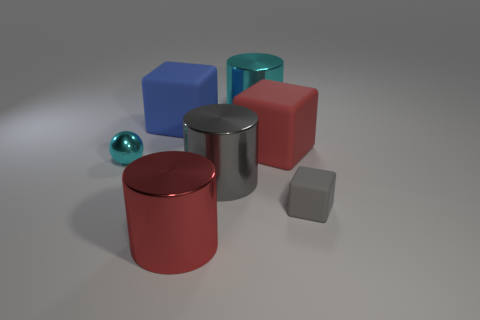Subtract all small cubes. How many cubes are left? 2 Add 1 purple rubber balls. How many objects exist? 8 Subtract 2 blocks. How many blocks are left? 1 Subtract all spheres. How many objects are left? 6 Subtract all cyan cylinders. Subtract all green cubes. How many cylinders are left? 2 Subtract all small cubes. Subtract all big red metal cylinders. How many objects are left? 5 Add 7 blue matte objects. How many blue matte objects are left? 8 Add 5 big blue metal cubes. How many big blue metal cubes exist? 5 Subtract 1 cyan cylinders. How many objects are left? 6 